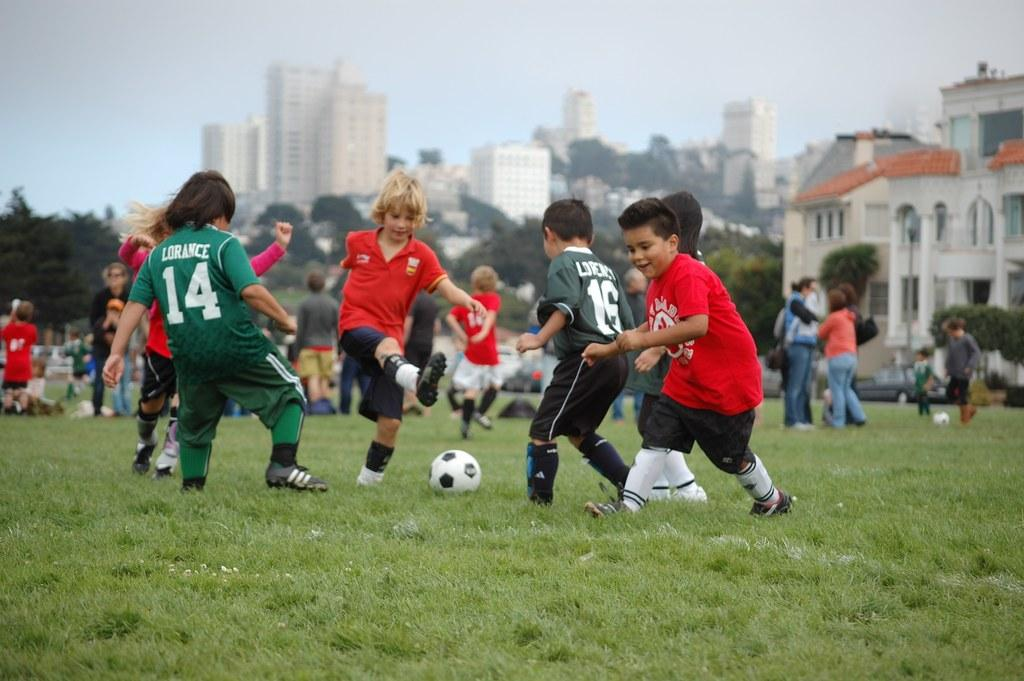<image>
Render a clear and concise summary of the photo. some kids playing soccer and one with the number 14 